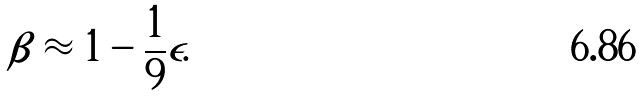Convert formula to latex. <formula><loc_0><loc_0><loc_500><loc_500>\beta \approx 1 - \frac { 1 } { 9 } \epsilon .</formula> 